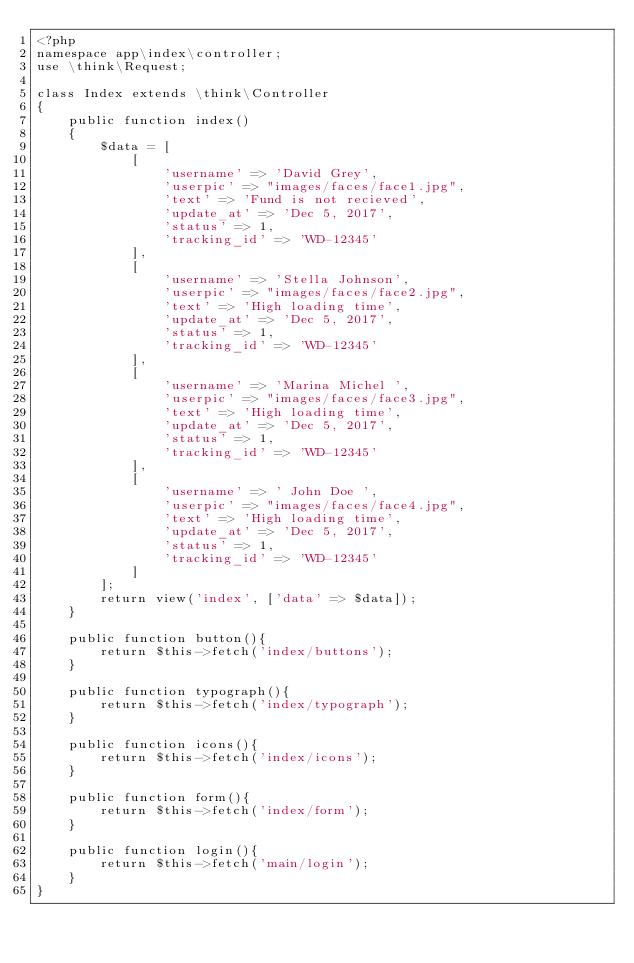<code> <loc_0><loc_0><loc_500><loc_500><_PHP_><?php
namespace app\index\controller;
use \think\Request;

class Index extends \think\Controller
{
    public function index()
    {
        $data = [
            [
                'username' => 'David Grey',
                'userpic' => "images/faces/face1.jpg",
                'text' => 'Fund is not recieved',
                'update_at' => 'Dec 5, 2017',
                'status' => 1,
                'tracking_id' => 'WD-12345'
            ],
            [
                'username' => 'Stella Johnson',
                'userpic' => "images/faces/face2.jpg",
                'text' => 'High loading time',
                'update_at' => 'Dec 5, 2017',
                'status' => 1,
                'tracking_id' => 'WD-12345'
            ],
            [
                'username' => 'Marina Michel ',
                'userpic' => "images/faces/face3.jpg",
                'text' => 'High loading time',
                'update_at' => 'Dec 5, 2017',
                'status' => 1,
                'tracking_id' => 'WD-12345'
            ],
            [
                'username' => ' John Doe ',
                'userpic' => "images/faces/face4.jpg",
                'text' => 'High loading time',
                'update_at' => 'Dec 5, 2017',
                'status' => 1,
                'tracking_id' => 'WD-12345'
            ]
        ];
        return view('index', ['data' => $data]);
    }

    public function button(){
        return $this->fetch('index/buttons');
    }

    public function typograph(){
        return $this->fetch('index/typograph');
    }

    public function icons(){
        return $this->fetch('index/icons');
    }

    public function form(){
        return $this->fetch('index/form');
    }

    public function login(){
        return $this->fetch('main/login');
    }
}
</code> 